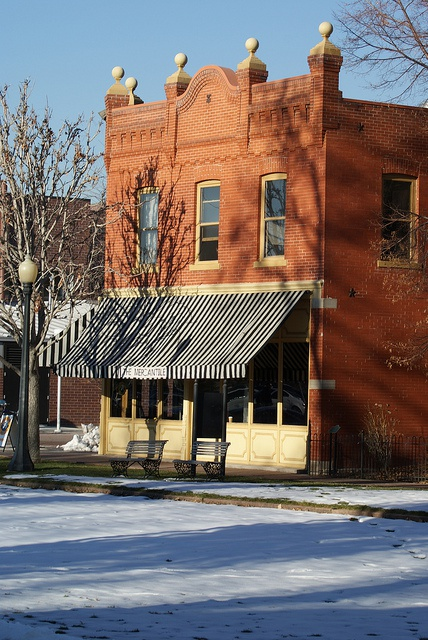Describe the objects in this image and their specific colors. I can see bench in lightblue, black, gray, and tan tones and bench in lightblue, black, gray, khaki, and darkgray tones in this image. 